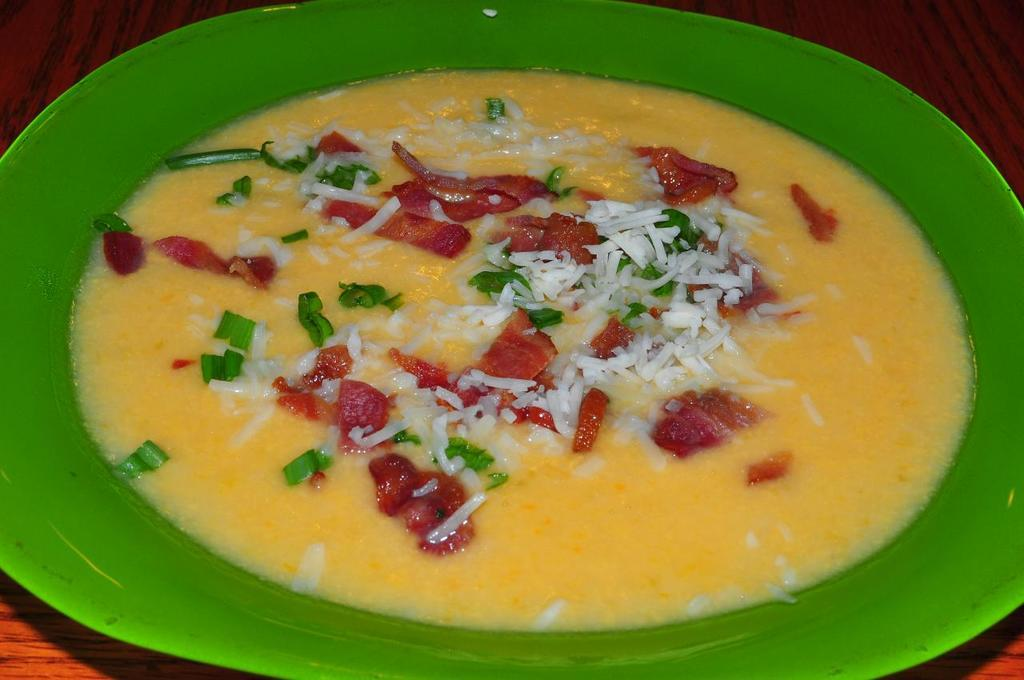What is the main subject of the image? The image is a closeup of a food item. What color is the plate that the food item is on? The food item is on a green plate. What type of surface is the green plate placed on? The green plate is placed on a wooden surface. What type of dress is the food item wearing in the image? The food item is not a person and therefore cannot wear a dress. 